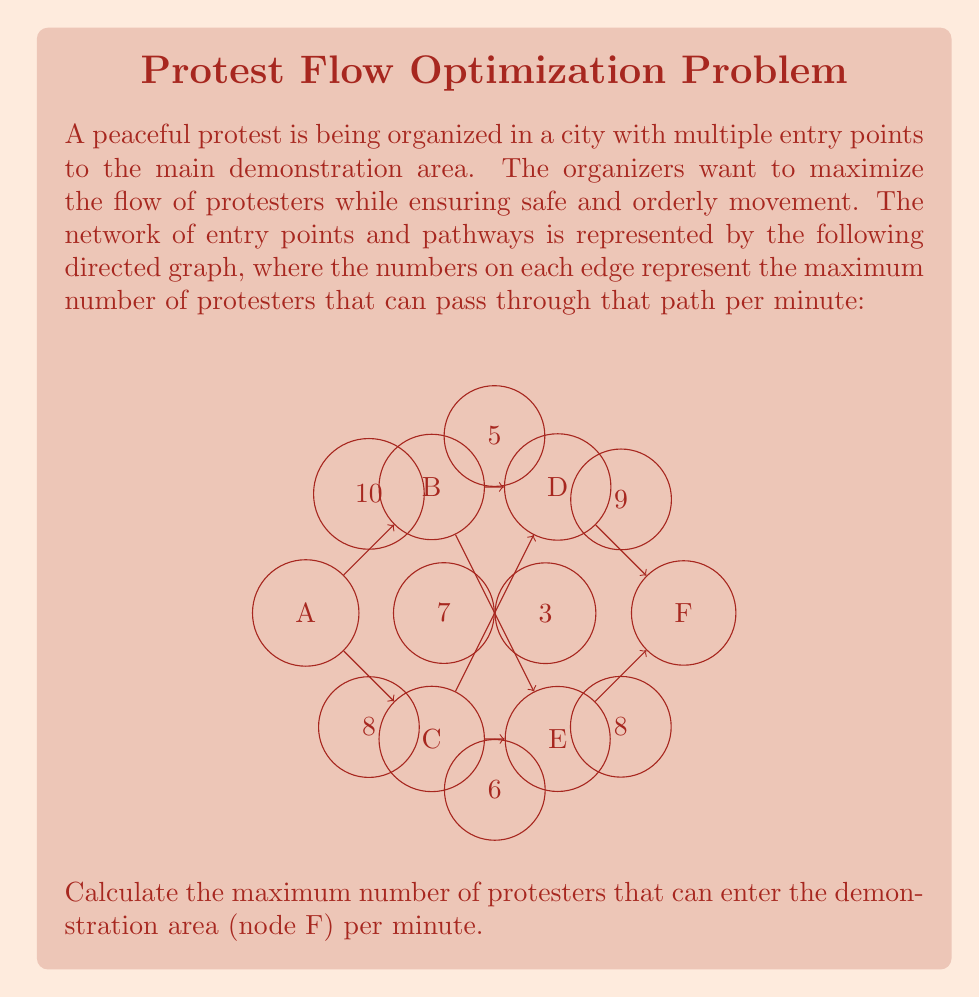Give your solution to this math problem. To solve this problem, we need to use the maximum flow algorithm, specifically the Ford-Fulkerson method. Here's a step-by-step explanation:

1) First, we identify the source (A) and sink (F) nodes in our network.

2) We then find augmenting paths from A to F and their bottleneck capacities:

   Path 1: A → B → D → F
   Bottleneck: min(10, 5, 9) = 5
   Flow: 5

   Path 2: A → C → E → F
   Bottleneck: min(8, 6, 8) = 6
   Flow: 6

   Path 3: A → B → E → F
   Bottleneck: min(10-5, 7, 8-6) = 2
   Flow: 2

   Path 4: A → C → D → F
   Bottleneck: min(8-6, 3, 9-5) = 2
   Flow: 2

3) No more augmenting paths exist, so we sum up the flows:

   Total maximum flow = 5 + 6 + 2 + 2 = 15

Therefore, the maximum number of protesters that can enter the demonstration area (node F) per minute is 15.
Answer: 15 protesters per minute 